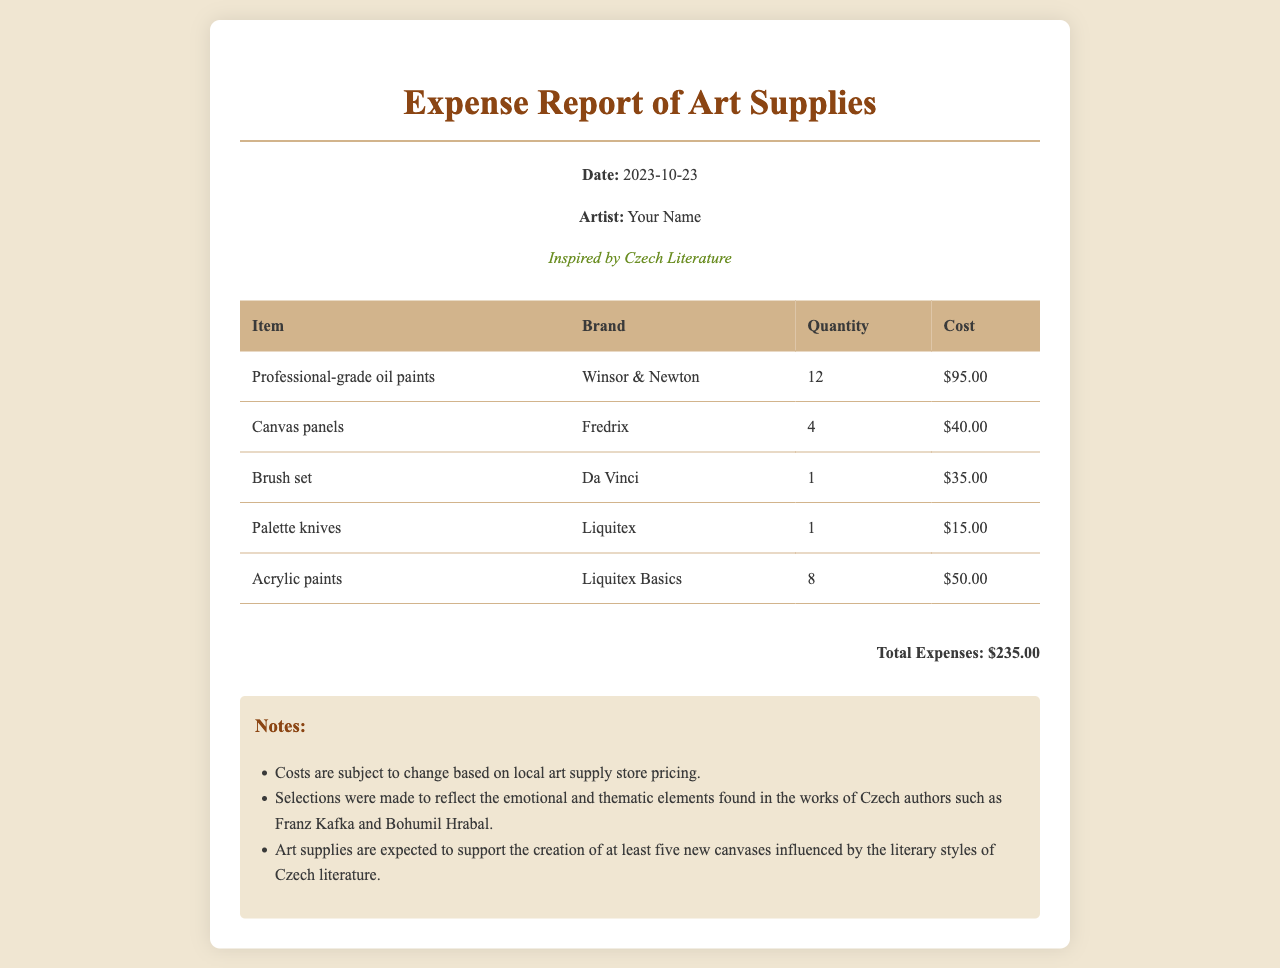what is the date of the expense report? The date of the expense report is specified in the header information section of the document.
Answer: 2023-10-23 who is the artist of the report? The artist's name is mentioned in the header information section of the document.
Answer: Your Name what is the total amount spent on art supplies? The total expenses are calculated at the end of the report, reflecting the sum of all individual costs.
Answer: $235.00 how many professional-grade oil paints were purchased? The quantity of professional-grade oil paints is listed in the table under the "Quantity" column for that item.
Answer: 12 which brand is associated with the canvas panels? The brand for the canvas panels is listed in the table next to the item.
Answer: Fredrix why were the art supplies selected? The selection rationale is given in the notes section, which references thematic elements from Czech literature.
Answer: Emotional and thematic elements how many new canvases are expected to be created with the purchased art supplies? The expectation regarding new canvases is mentioned in the notes section of the report.
Answer: Five what type of brush was purchased? The specific type of brush is identified in the description within the table.
Answer: Brush set what is the cost of the palette knives? The cost for the palette knives is stated in the corresponding cell of the table.
Answer: $15.00 